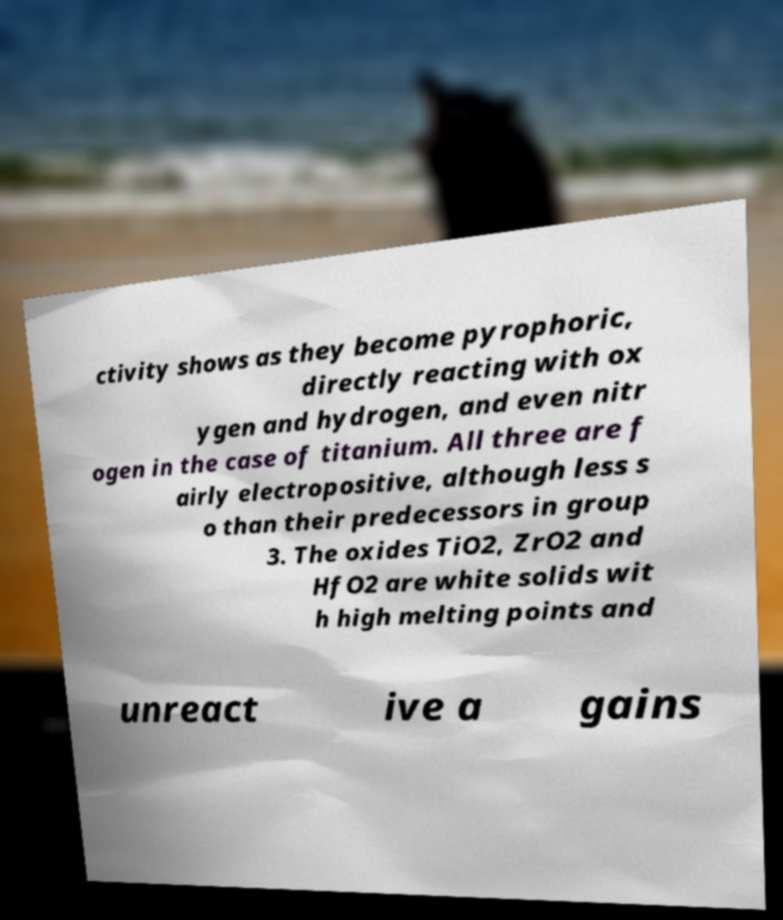For documentation purposes, I need the text within this image transcribed. Could you provide that? ctivity shows as they become pyrophoric, directly reacting with ox ygen and hydrogen, and even nitr ogen in the case of titanium. All three are f airly electropositive, although less s o than their predecessors in group 3. The oxides TiO2, ZrO2 and HfO2 are white solids wit h high melting points and unreact ive a gains 